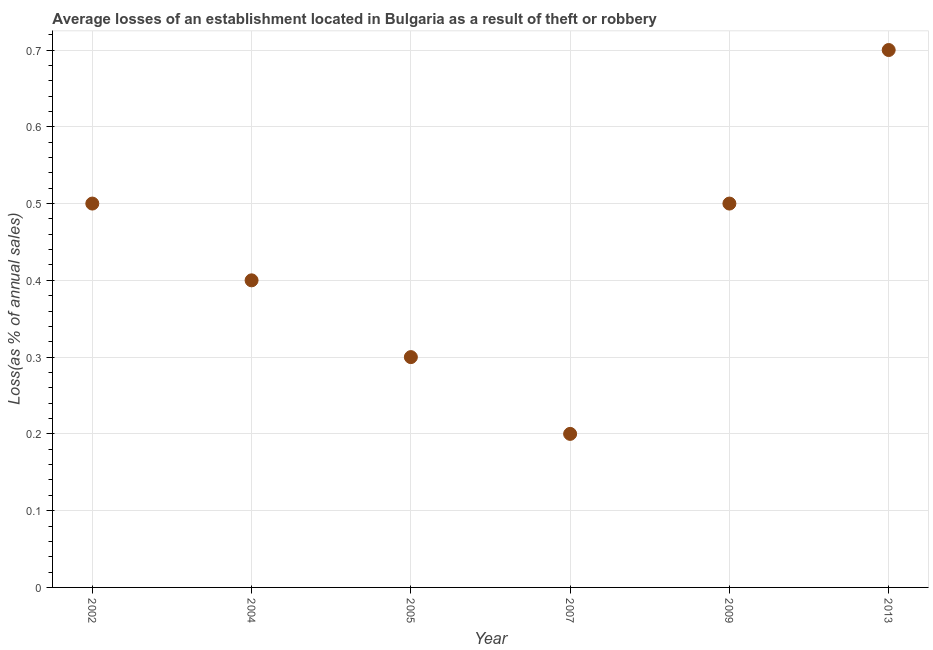What is the sum of the losses due to theft?
Your response must be concise. 2.6. What is the difference between the losses due to theft in 2004 and 2013?
Make the answer very short. -0.3. What is the average losses due to theft per year?
Make the answer very short. 0.43. What is the median losses due to theft?
Give a very brief answer. 0.45. In how many years, is the losses due to theft greater than 0.36000000000000004 %?
Make the answer very short. 4. Do a majority of the years between 2009 and 2013 (inclusive) have losses due to theft greater than 0.2 %?
Offer a very short reply. Yes. Is the losses due to theft in 2002 less than that in 2004?
Offer a very short reply. No. What is the difference between the highest and the second highest losses due to theft?
Offer a terse response. 0.2. Is the sum of the losses due to theft in 2002 and 2007 greater than the maximum losses due to theft across all years?
Your answer should be very brief. No. What is the difference between the highest and the lowest losses due to theft?
Give a very brief answer. 0.5. In how many years, is the losses due to theft greater than the average losses due to theft taken over all years?
Ensure brevity in your answer.  3. How many dotlines are there?
Your response must be concise. 1. What is the difference between two consecutive major ticks on the Y-axis?
Give a very brief answer. 0.1. Are the values on the major ticks of Y-axis written in scientific E-notation?
Provide a short and direct response. No. Does the graph contain grids?
Make the answer very short. Yes. What is the title of the graph?
Give a very brief answer. Average losses of an establishment located in Bulgaria as a result of theft or robbery. What is the label or title of the Y-axis?
Offer a very short reply. Loss(as % of annual sales). What is the Loss(as % of annual sales) in 2002?
Offer a very short reply. 0.5. What is the Loss(as % of annual sales) in 2005?
Give a very brief answer. 0.3. What is the difference between the Loss(as % of annual sales) in 2002 and 2004?
Ensure brevity in your answer.  0.1. What is the difference between the Loss(as % of annual sales) in 2002 and 2005?
Your response must be concise. 0.2. What is the difference between the Loss(as % of annual sales) in 2002 and 2007?
Keep it short and to the point. 0.3. What is the difference between the Loss(as % of annual sales) in 2004 and 2005?
Ensure brevity in your answer.  0.1. What is the difference between the Loss(as % of annual sales) in 2004 and 2009?
Make the answer very short. -0.1. What is the difference between the Loss(as % of annual sales) in 2004 and 2013?
Provide a short and direct response. -0.3. What is the difference between the Loss(as % of annual sales) in 2005 and 2009?
Ensure brevity in your answer.  -0.2. What is the difference between the Loss(as % of annual sales) in 2005 and 2013?
Provide a succinct answer. -0.4. What is the difference between the Loss(as % of annual sales) in 2007 and 2009?
Offer a very short reply. -0.3. What is the difference between the Loss(as % of annual sales) in 2007 and 2013?
Your answer should be very brief. -0.5. What is the ratio of the Loss(as % of annual sales) in 2002 to that in 2005?
Keep it short and to the point. 1.67. What is the ratio of the Loss(as % of annual sales) in 2002 to that in 2013?
Make the answer very short. 0.71. What is the ratio of the Loss(as % of annual sales) in 2004 to that in 2005?
Make the answer very short. 1.33. What is the ratio of the Loss(as % of annual sales) in 2004 to that in 2013?
Provide a short and direct response. 0.57. What is the ratio of the Loss(as % of annual sales) in 2005 to that in 2007?
Make the answer very short. 1.5. What is the ratio of the Loss(as % of annual sales) in 2005 to that in 2013?
Make the answer very short. 0.43. What is the ratio of the Loss(as % of annual sales) in 2007 to that in 2009?
Make the answer very short. 0.4. What is the ratio of the Loss(as % of annual sales) in 2007 to that in 2013?
Your answer should be compact. 0.29. What is the ratio of the Loss(as % of annual sales) in 2009 to that in 2013?
Provide a short and direct response. 0.71. 